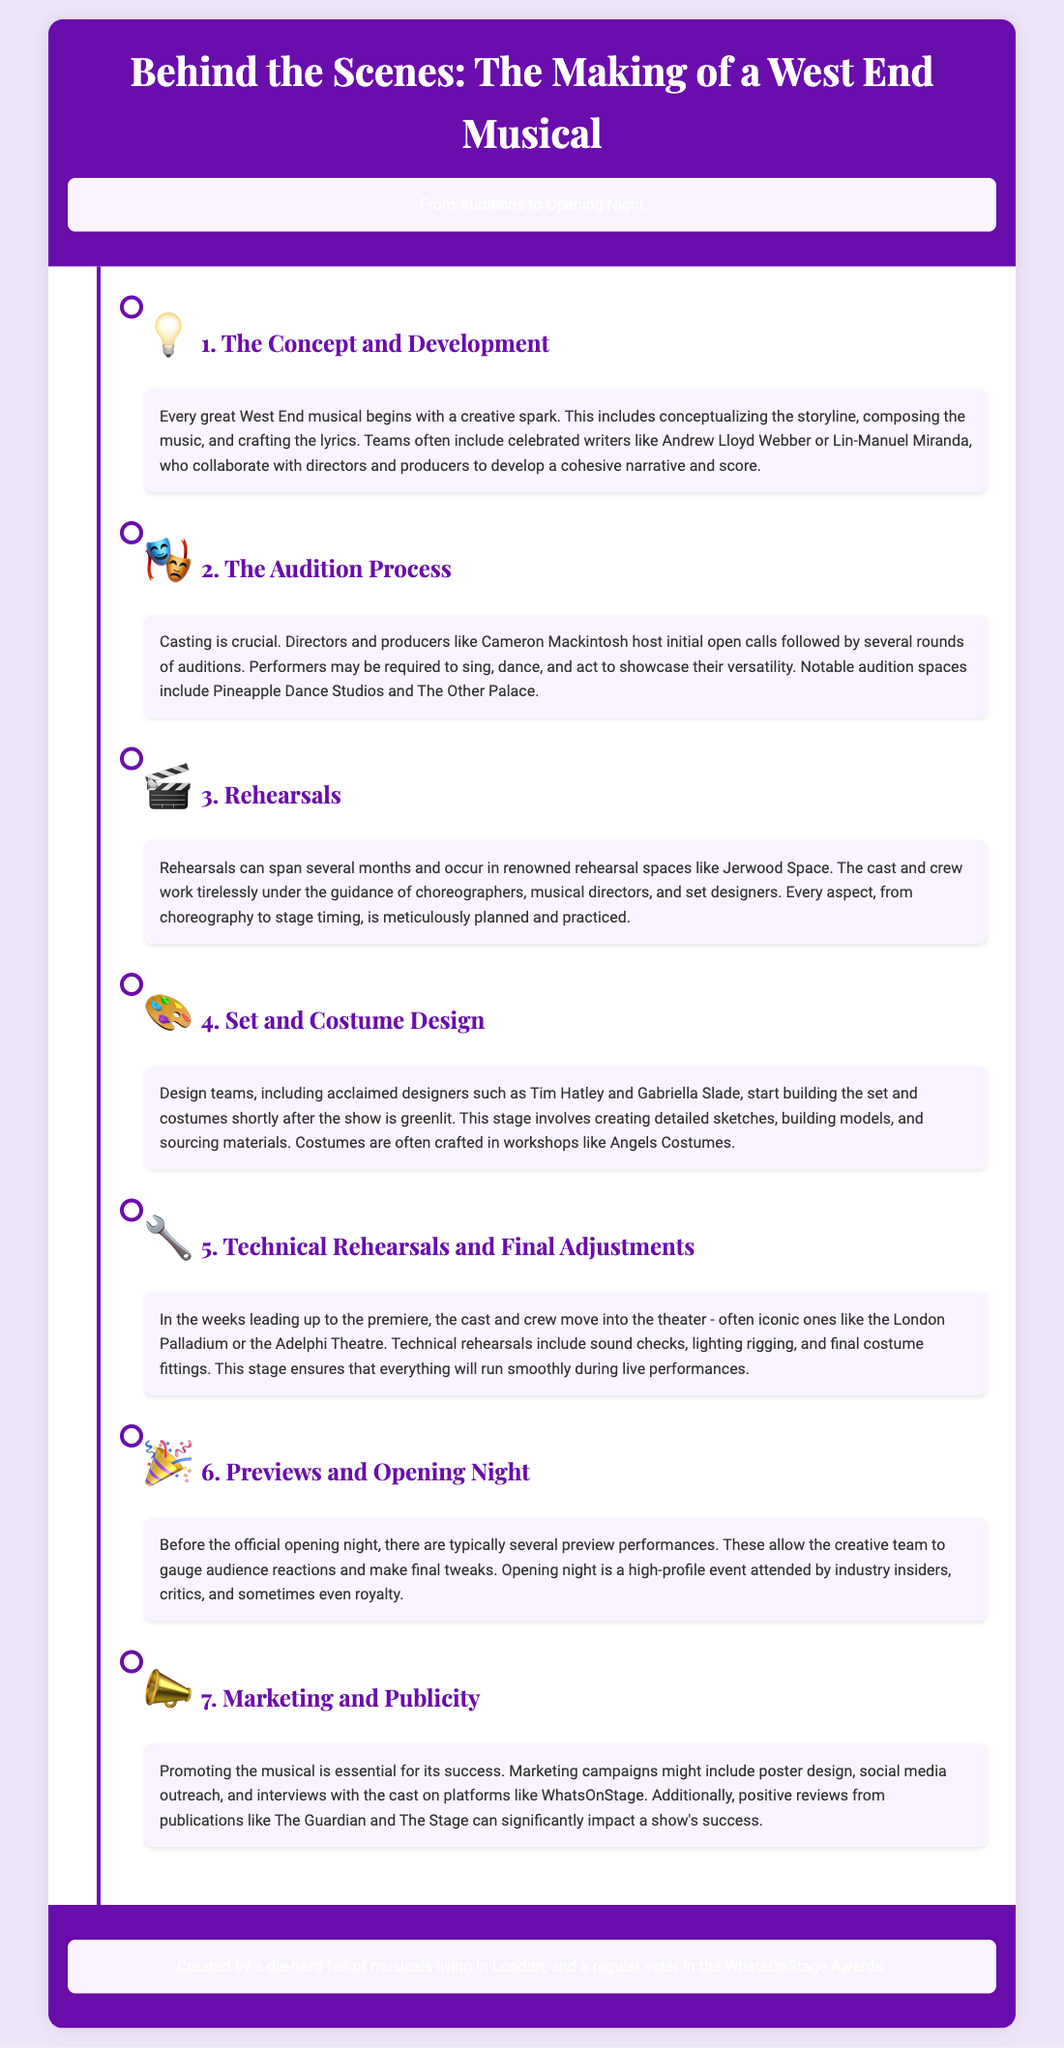What is crucial for casting a musical? The document states that casting is crucial and involves showcasing versatility through singing, dancing, and acting during auditions.
Answer: Casting Who are notable writers mentioned in the concept development? The document highlights celebrated writers such as Andrew Lloyd Webber and Lin-Manuel Miranda.
Answer: Andrew Lloyd Webber, Lin-Manuel Miranda Where do auditions often take place? The document lists notable audition spaces, specifically Pineapple Dance Studios and The Other Palace.
Answer: Pineapple Dance Studios, The Other Palace What is the focus during technical rehearsals? The document mentions sound checks, lighting rigging, and final costume fittings as focal points during technical rehearsals.
Answer: Sound checks, lighting rigging, final costume fittings Who typically attends opening night? The document indicates that industry insiders, critics, and sometimes royalty attend the opening night.
Answer: Industry insiders, critics, royalty When do previews typically occur? The document states that previews occur before the official opening night and allow the creative team to gauge audience reactions.
Answer: Before the official opening night What is a major component of promoting a musical? The document lists marketing campaigns, including poster design and social media outreach, as major promotional components.
Answer: Marketing campaigns Which theatre is mentioned in relation to technical rehearsals? The document refers to iconic theatres like the London Palladium and the Adelphi Theatre for technical rehearsals.
Answer: London Palladium, Adelphi Theatre 